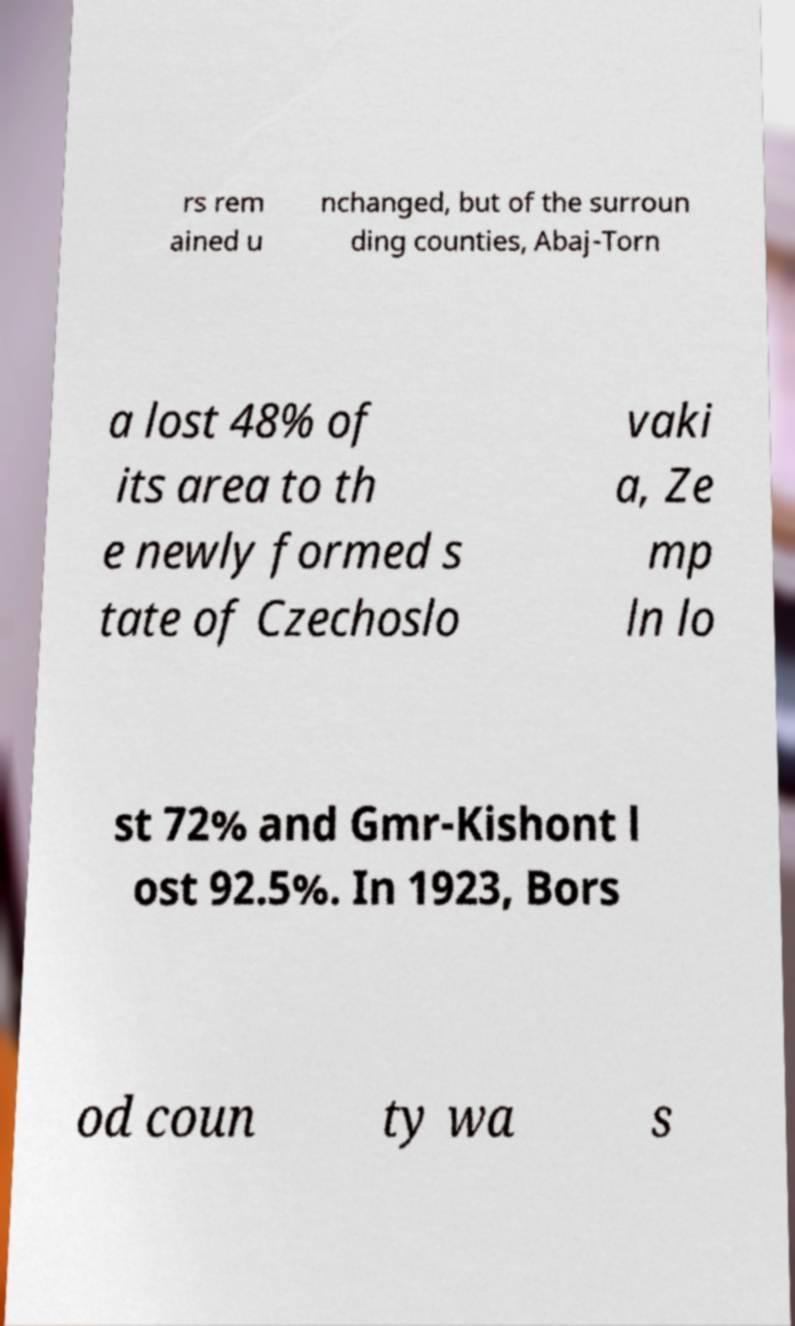Could you extract and type out the text from this image? rs rem ained u nchanged, but of the surroun ding counties, Abaj-Torn a lost 48% of its area to th e newly formed s tate of Czechoslo vaki a, Ze mp ln lo st 72% and Gmr-Kishont l ost 92.5%. In 1923, Bors od coun ty wa s 